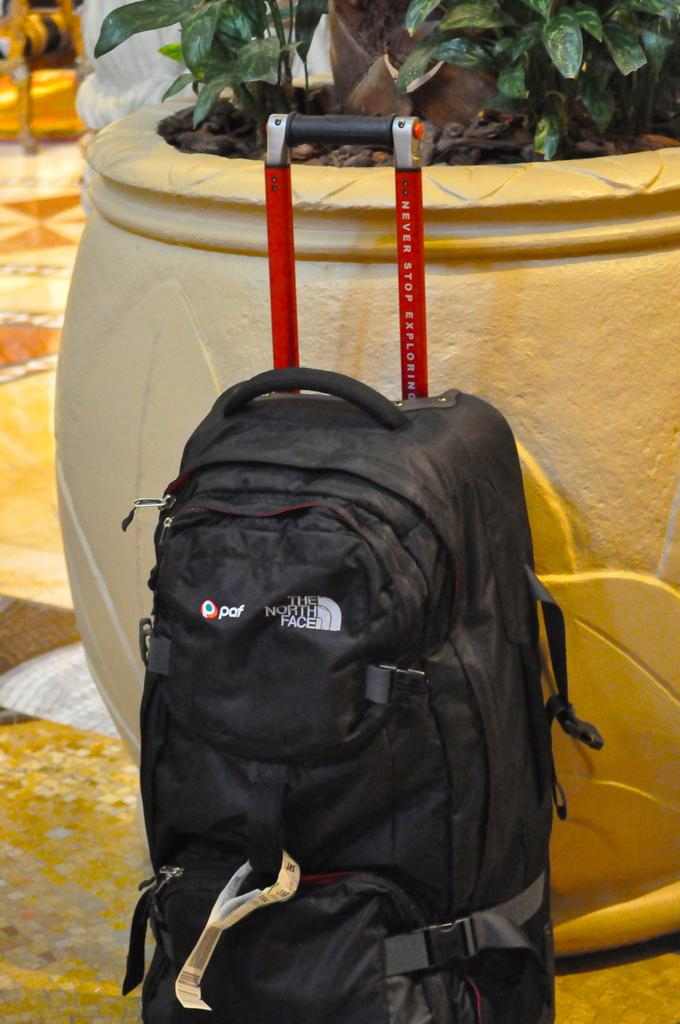What is the main object in the center of the image? There is a backpack in the center of the image. What color is the backpack? The backpack is black in color. What can be seen in the background of the image? There is a pot and a plant in the background of the image. What story is being told by the sky in the image? There is no sky visible in the image, so no story can be told by the sky. 